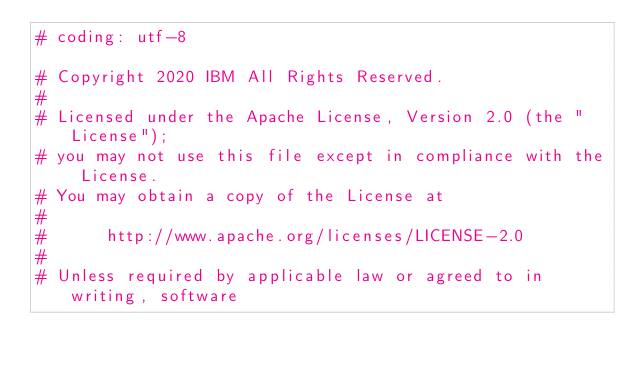<code> <loc_0><loc_0><loc_500><loc_500><_Python_># coding: utf-8

# Copyright 2020 IBM All Rights Reserved.
#
# Licensed under the Apache License, Version 2.0 (the "License");
# you may not use this file except in compliance with the License.
# You may obtain a copy of the License at
#
#      http://www.apache.org/licenses/LICENSE-2.0
#
# Unless required by applicable law or agreed to in writing, software</code> 